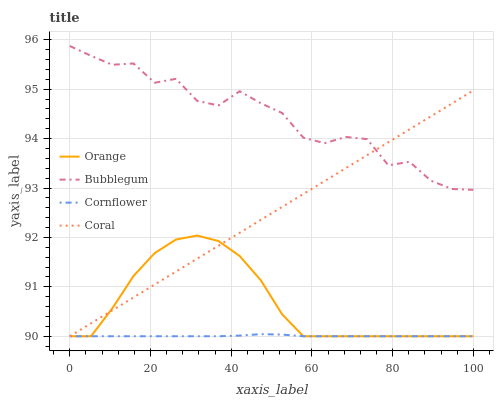Does Cornflower have the minimum area under the curve?
Answer yes or no. Yes. Does Bubblegum have the maximum area under the curve?
Answer yes or no. Yes. Does Coral have the minimum area under the curve?
Answer yes or no. No. Does Coral have the maximum area under the curve?
Answer yes or no. No. Is Coral the smoothest?
Answer yes or no. Yes. Is Bubblegum the roughest?
Answer yes or no. Yes. Is Cornflower the smoothest?
Answer yes or no. No. Is Cornflower the roughest?
Answer yes or no. No. Does Orange have the lowest value?
Answer yes or no. Yes. Does Bubblegum have the lowest value?
Answer yes or no. No. Does Bubblegum have the highest value?
Answer yes or no. Yes. Does Coral have the highest value?
Answer yes or no. No. Is Cornflower less than Bubblegum?
Answer yes or no. Yes. Is Bubblegum greater than Cornflower?
Answer yes or no. Yes. Does Bubblegum intersect Coral?
Answer yes or no. Yes. Is Bubblegum less than Coral?
Answer yes or no. No. Is Bubblegum greater than Coral?
Answer yes or no. No. Does Cornflower intersect Bubblegum?
Answer yes or no. No. 